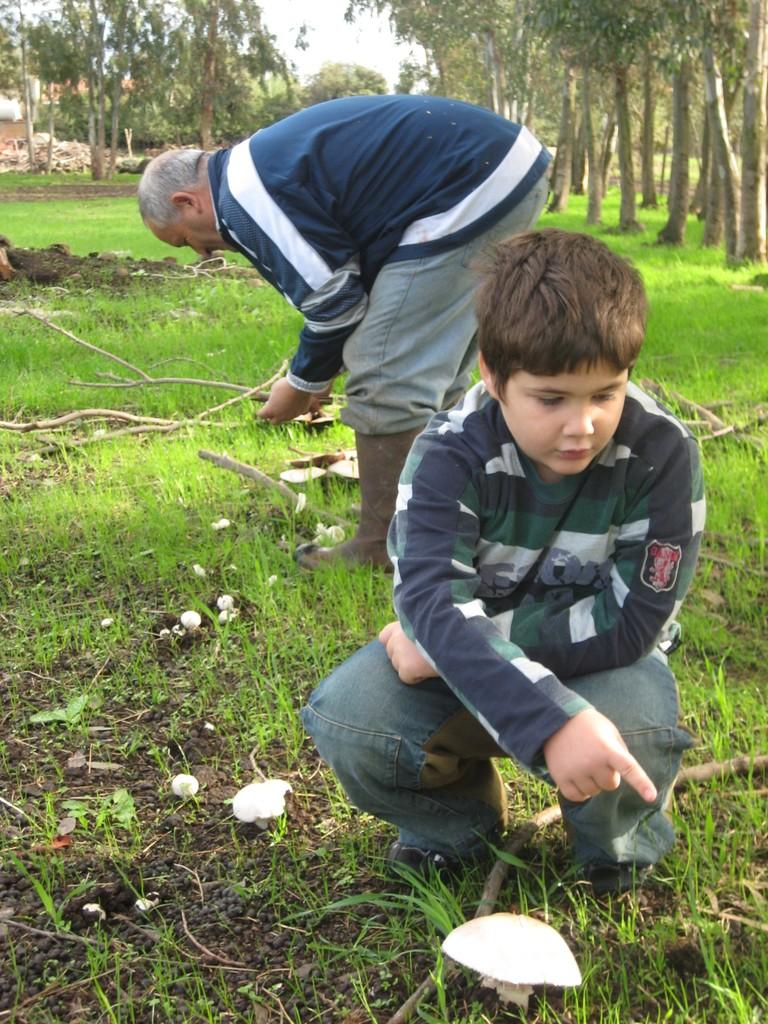Who are the people present in the image? There is a boy and a man in the image. What can be seen in the background of the image? There are trees, grass, and the sky visible in the background of the image. What type of basin is being used by the boy in the image? There is no basin present in the image. How are the boy and the man sorting the existence of objects in the image? The boy and the man are not sorting the existence of objects in the image; they are simply present in the image. 